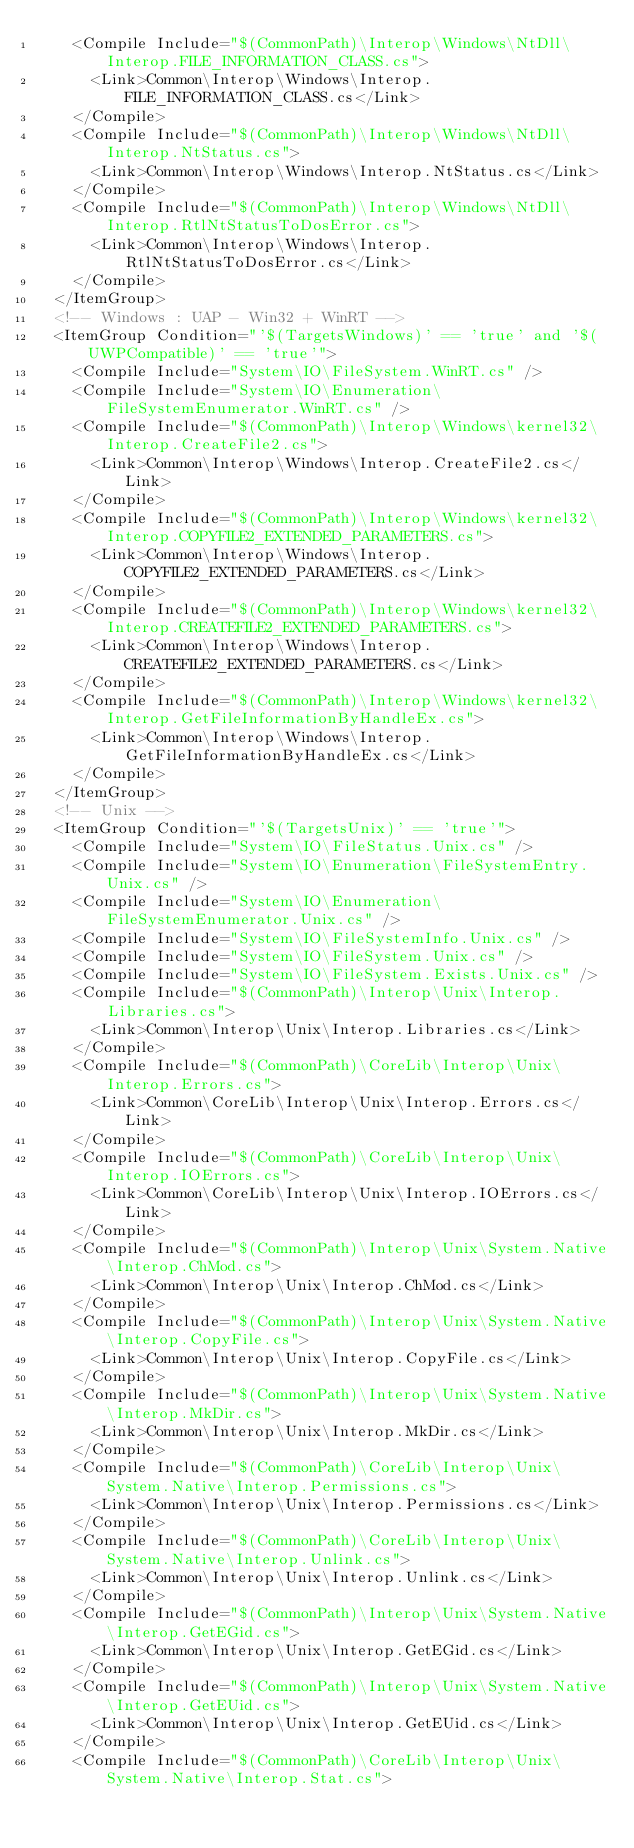Convert code to text. <code><loc_0><loc_0><loc_500><loc_500><_XML_>    <Compile Include="$(CommonPath)\Interop\Windows\NtDll\Interop.FILE_INFORMATION_CLASS.cs">
      <Link>Common\Interop\Windows\Interop.FILE_INFORMATION_CLASS.cs</Link>
    </Compile>
    <Compile Include="$(CommonPath)\Interop\Windows\NtDll\Interop.NtStatus.cs">
      <Link>Common\Interop\Windows\Interop.NtStatus.cs</Link>
    </Compile>
    <Compile Include="$(CommonPath)\Interop\Windows\NtDll\Interop.RtlNtStatusToDosError.cs">
      <Link>Common\Interop\Windows\Interop.RtlNtStatusToDosError.cs</Link>
    </Compile>
  </ItemGroup>
  <!-- Windows : UAP - Win32 + WinRT -->
  <ItemGroup Condition="'$(TargetsWindows)' == 'true' and '$(UWPCompatible)' == 'true'">
    <Compile Include="System\IO\FileSystem.WinRT.cs" />
    <Compile Include="System\IO\Enumeration\FileSystemEnumerator.WinRT.cs" />
    <Compile Include="$(CommonPath)\Interop\Windows\kernel32\Interop.CreateFile2.cs">
      <Link>Common\Interop\Windows\Interop.CreateFile2.cs</Link>
    </Compile>
    <Compile Include="$(CommonPath)\Interop\Windows\kernel32\Interop.COPYFILE2_EXTENDED_PARAMETERS.cs">
      <Link>Common\Interop\Windows\Interop.COPYFILE2_EXTENDED_PARAMETERS.cs</Link>
    </Compile>
    <Compile Include="$(CommonPath)\Interop\Windows\kernel32\Interop.CREATEFILE2_EXTENDED_PARAMETERS.cs">
      <Link>Common\Interop\Windows\Interop.CREATEFILE2_EXTENDED_PARAMETERS.cs</Link>
    </Compile>
    <Compile Include="$(CommonPath)\Interop\Windows\kernel32\Interop.GetFileInformationByHandleEx.cs">
      <Link>Common\Interop\Windows\Interop.GetFileInformationByHandleEx.cs</Link>
    </Compile>
  </ItemGroup>
  <!-- Unix -->
  <ItemGroup Condition="'$(TargetsUnix)' == 'true'">
    <Compile Include="System\IO\FileStatus.Unix.cs" />
    <Compile Include="System\IO\Enumeration\FileSystemEntry.Unix.cs" />
    <Compile Include="System\IO\Enumeration\FileSystemEnumerator.Unix.cs" />
    <Compile Include="System\IO\FileSystemInfo.Unix.cs" />
    <Compile Include="System\IO\FileSystem.Unix.cs" />
    <Compile Include="System\IO\FileSystem.Exists.Unix.cs" />
    <Compile Include="$(CommonPath)\Interop\Unix\Interop.Libraries.cs">
      <Link>Common\Interop\Unix\Interop.Libraries.cs</Link>
    </Compile>
    <Compile Include="$(CommonPath)\CoreLib\Interop\Unix\Interop.Errors.cs">
      <Link>Common\CoreLib\Interop\Unix\Interop.Errors.cs</Link>
    </Compile>
    <Compile Include="$(CommonPath)\CoreLib\Interop\Unix\Interop.IOErrors.cs">
      <Link>Common\CoreLib\Interop\Unix\Interop.IOErrors.cs</Link>
    </Compile>
    <Compile Include="$(CommonPath)\Interop\Unix\System.Native\Interop.ChMod.cs">
      <Link>Common\Interop\Unix\Interop.ChMod.cs</Link>
    </Compile>
    <Compile Include="$(CommonPath)\Interop\Unix\System.Native\Interop.CopyFile.cs">
      <Link>Common\Interop\Unix\Interop.CopyFile.cs</Link>
    </Compile>
    <Compile Include="$(CommonPath)\Interop\Unix\System.Native\Interop.MkDir.cs">
      <Link>Common\Interop\Unix\Interop.MkDir.cs</Link>
    </Compile>
    <Compile Include="$(CommonPath)\CoreLib\Interop\Unix\System.Native\Interop.Permissions.cs">
      <Link>Common\Interop\Unix\Interop.Permissions.cs</Link>
    </Compile>
    <Compile Include="$(CommonPath)\CoreLib\Interop\Unix\System.Native\Interop.Unlink.cs">
      <Link>Common\Interop\Unix\Interop.Unlink.cs</Link>
    </Compile>
    <Compile Include="$(CommonPath)\Interop\Unix\System.Native\Interop.GetEGid.cs">
      <Link>Common\Interop\Unix\Interop.GetEGid.cs</Link>
    </Compile>
    <Compile Include="$(CommonPath)\Interop\Unix\System.Native\Interop.GetEUid.cs">
      <Link>Common\Interop\Unix\Interop.GetEUid.cs</Link>
    </Compile>
    <Compile Include="$(CommonPath)\CoreLib\Interop\Unix\System.Native\Interop.Stat.cs"></code> 